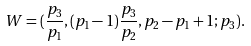<formula> <loc_0><loc_0><loc_500><loc_500>W = ( \frac { p _ { 3 } } { p _ { 1 } } , ( p _ { 1 } - 1 ) \frac { p _ { 3 } } { p _ { 2 } } , p _ { 2 } - p _ { 1 } + 1 ; p _ { 3 } ) .</formula> 